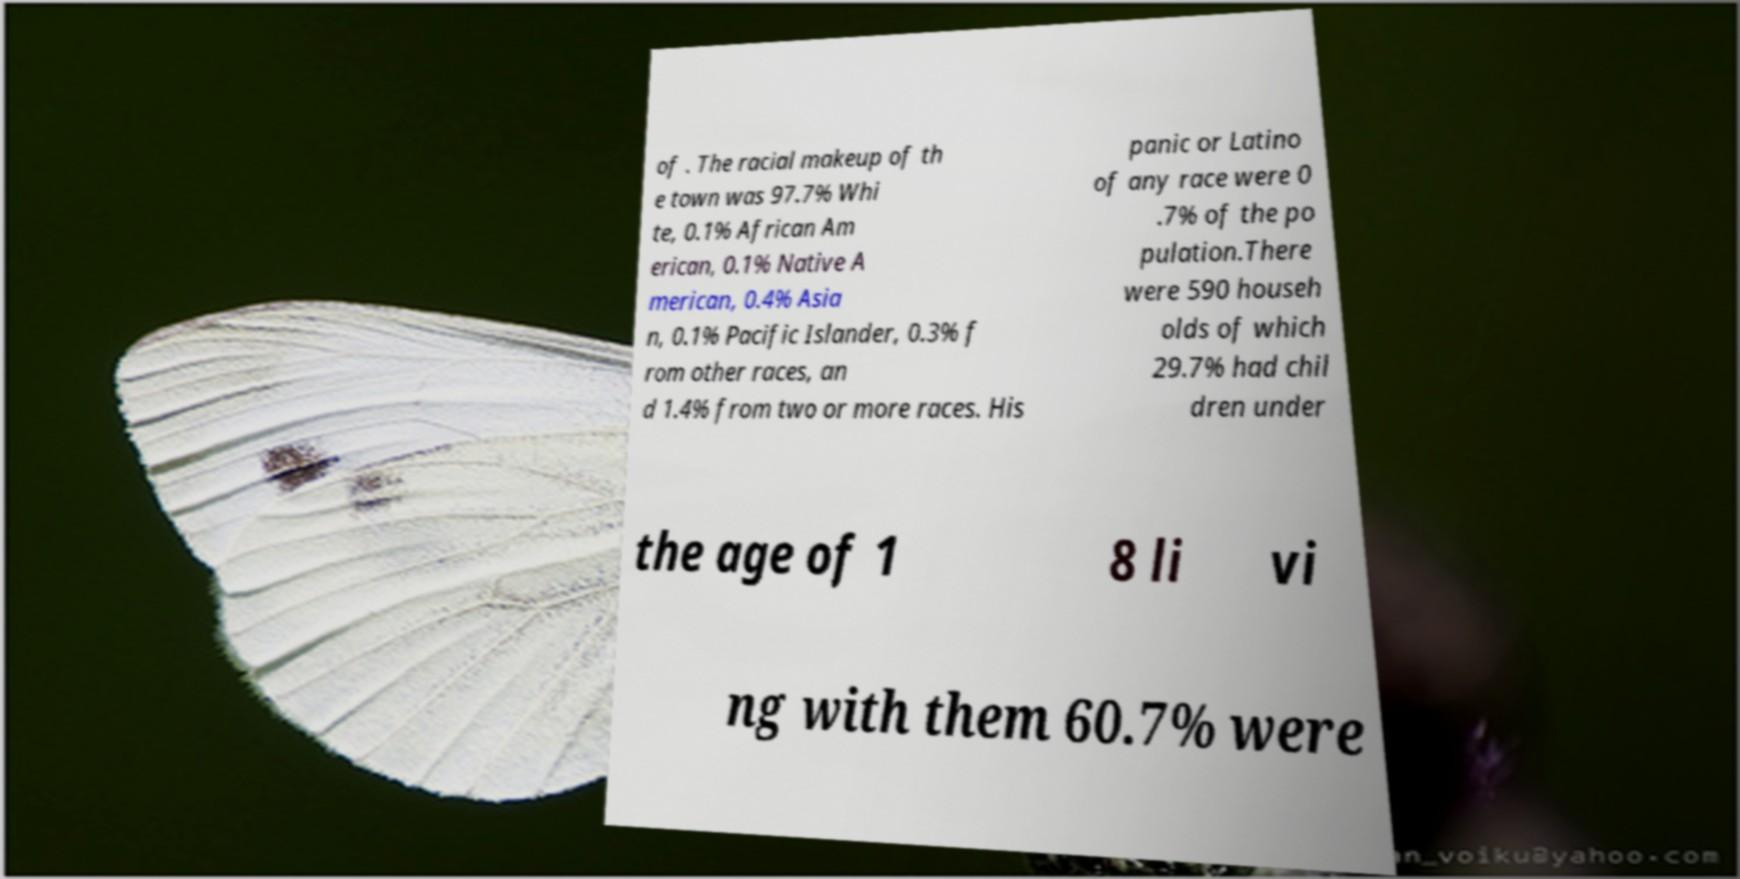Could you assist in decoding the text presented in this image and type it out clearly? of . The racial makeup of th e town was 97.7% Whi te, 0.1% African Am erican, 0.1% Native A merican, 0.4% Asia n, 0.1% Pacific Islander, 0.3% f rom other races, an d 1.4% from two or more races. His panic or Latino of any race were 0 .7% of the po pulation.There were 590 househ olds of which 29.7% had chil dren under the age of 1 8 li vi ng with them 60.7% were 